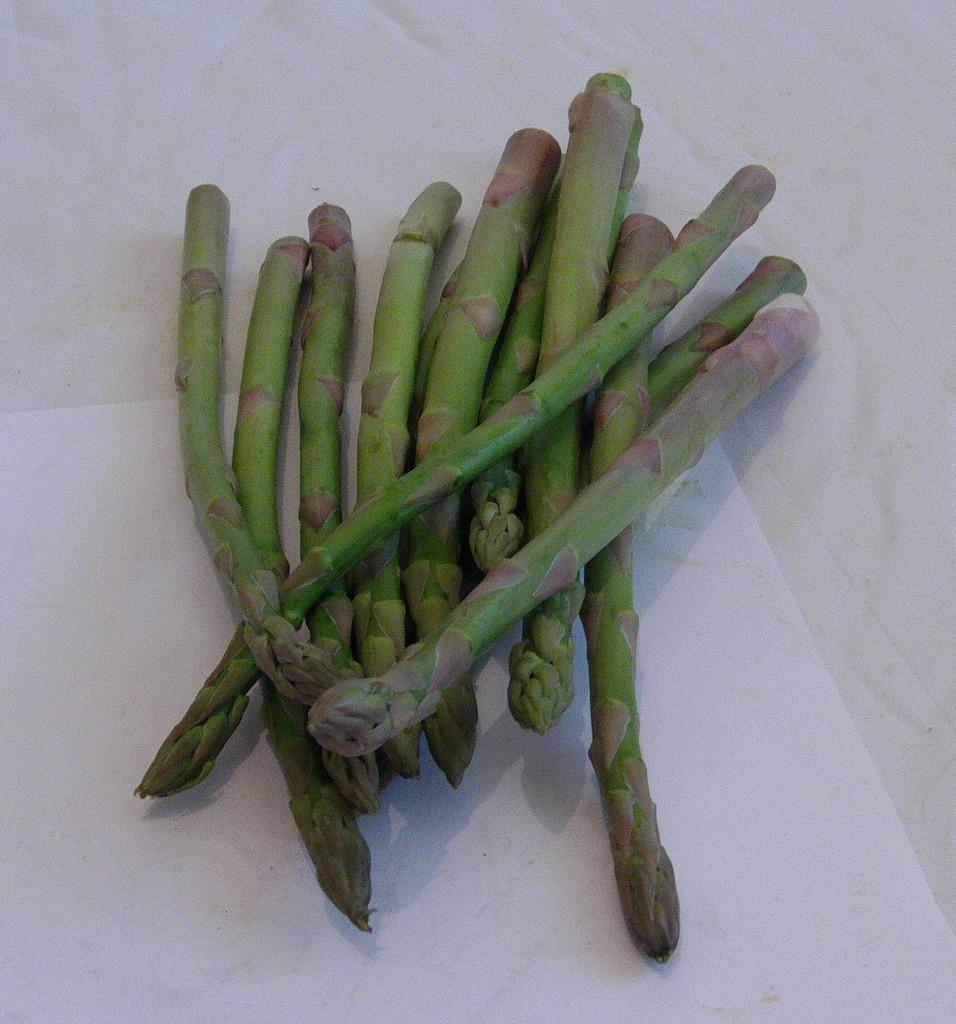What type of plant parts are visible in the image? There are plant stems in the image. What color is the surface beneath the plant stems? The surface beneath the plant stems is white. How much money is being exchanged between the parent and child in the image? There is no parent, child, or money present in the image; it only features plant stems and a white surface. 